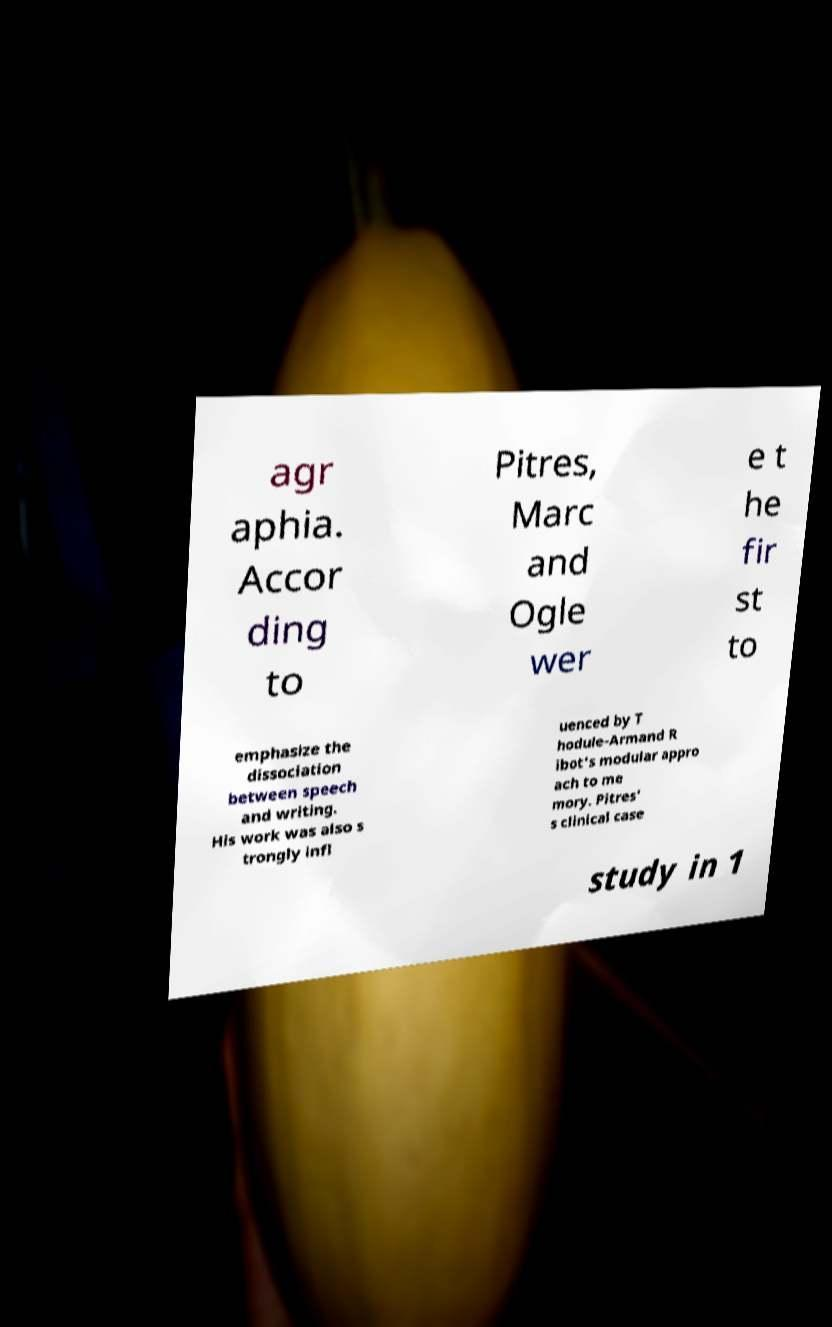Can you read and provide the text displayed in the image?This photo seems to have some interesting text. Can you extract and type it out for me? agr aphia. Accor ding to Pitres, Marc and Ogle wer e t he fir st to emphasize the dissociation between speech and writing. His work was also s trongly infl uenced by T hodule-Armand R ibot's modular appro ach to me mory. Pitres' s clinical case study in 1 